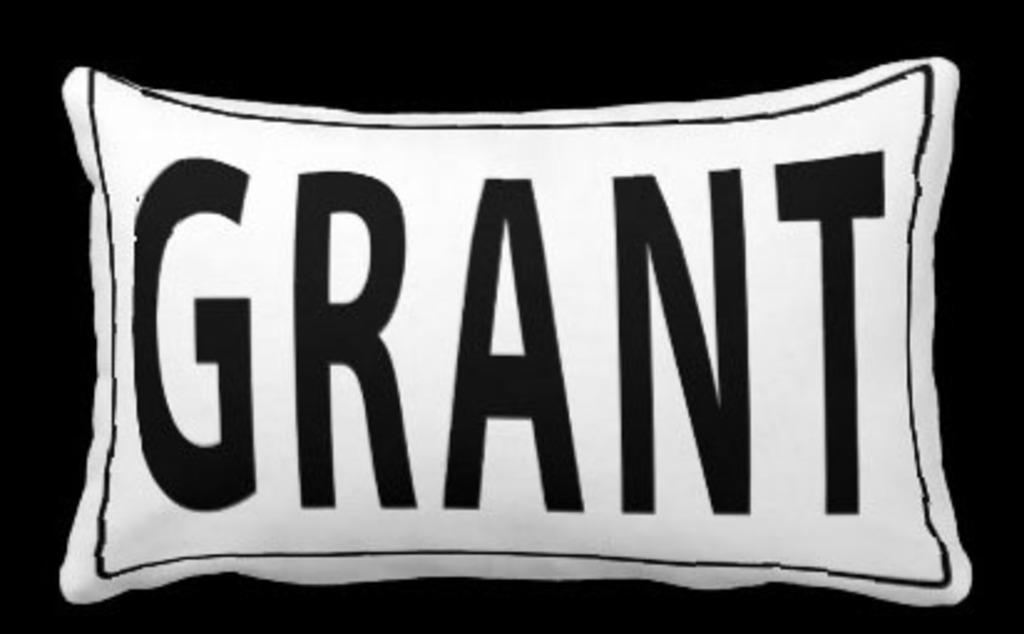What object is white in the image? There is a white pillow in the image. What is on the pillow? There is writing on the pillow. What color is the background of the image? The background of the image is black. How far away is the committee from the pillow in the image? There is no committee present in the image, so it is not possible to determine the distance between it and the pillow. 